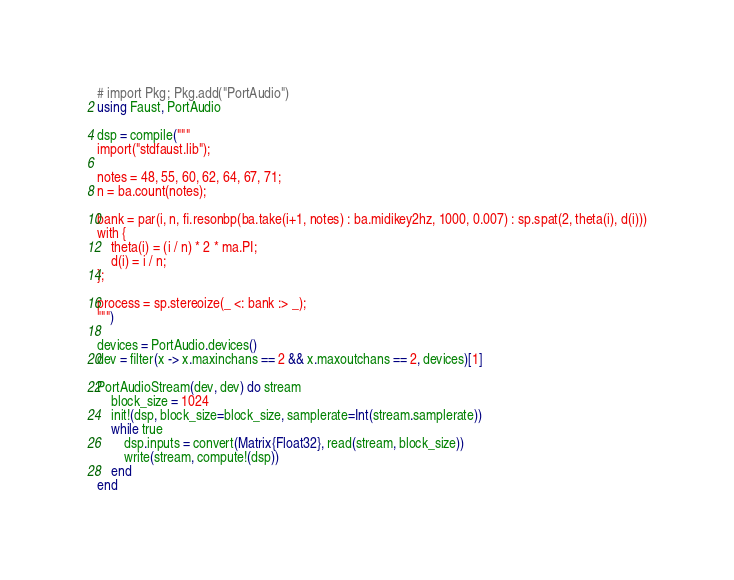Convert code to text. <code><loc_0><loc_0><loc_500><loc_500><_Julia_># import Pkg; Pkg.add("PortAudio")
using Faust, PortAudio

dsp = compile("""
import("stdfaust.lib");

notes = 48, 55, 60, 62, 64, 67, 71;
n = ba.count(notes);

bank = par(i, n, fi.resonbp(ba.take(i+1, notes) : ba.midikey2hz, 1000, 0.007) : sp.spat(2, theta(i), d(i)))
with {
    theta(i) = (i / n) * 2 * ma.PI;
    d(i) = i / n;
};

process = sp.stereoize(_ <: bank :> _);
""")

devices = PortAudio.devices()
dev = filter(x -> x.maxinchans == 2 && x.maxoutchans == 2, devices)[1]

PortAudioStream(dev, dev) do stream
    block_size = 1024
    init!(dsp, block_size=block_size, samplerate=Int(stream.samplerate))
    while true
        dsp.inputs = convert(Matrix{Float32}, read(stream, block_size))
        write(stream, compute!(dsp))
    end
end
</code> 